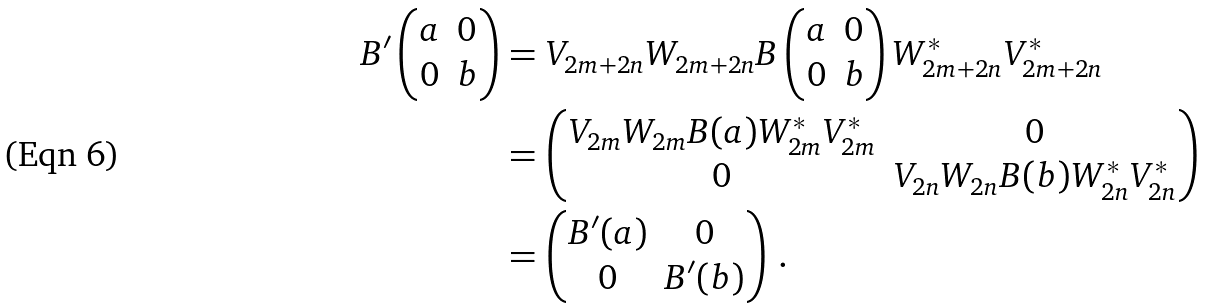Convert formula to latex. <formula><loc_0><loc_0><loc_500><loc_500>B ^ { \prime } \begin{pmatrix} a & 0 \\ 0 & b \end{pmatrix} & = V _ { 2 m + 2 n } W _ { 2 m + 2 n } B \left ( \begin{matrix} a & 0 \\ 0 & b \end{matrix} \right ) W _ { 2 m + 2 n } ^ { * } V _ { 2 m + 2 n } ^ { * } \\ & = \begin{pmatrix} V _ { 2 m } W _ { 2 m } B ( a ) W _ { 2 m } ^ { * } V _ { 2 m } ^ { * } & 0 \\ 0 & V _ { 2 n } W _ { 2 n } B ( b ) W _ { 2 n } ^ { * } V _ { 2 n } ^ { * } \end{pmatrix} \\ & = \begin{pmatrix} B ^ { \prime } ( a ) & 0 \\ 0 & B ^ { \prime } ( b ) \end{pmatrix} \, .</formula> 